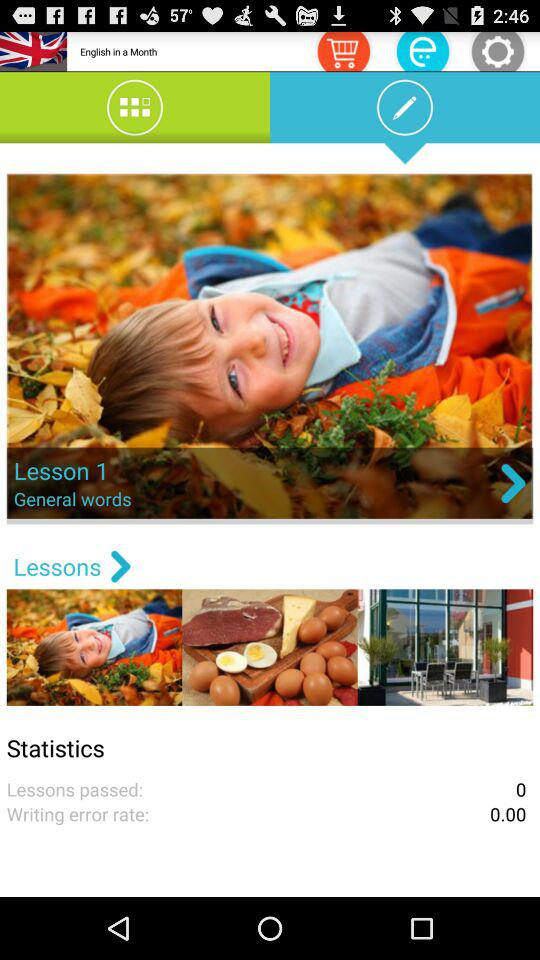What is the currently shown lesson? The currently shown lesson is 1. 